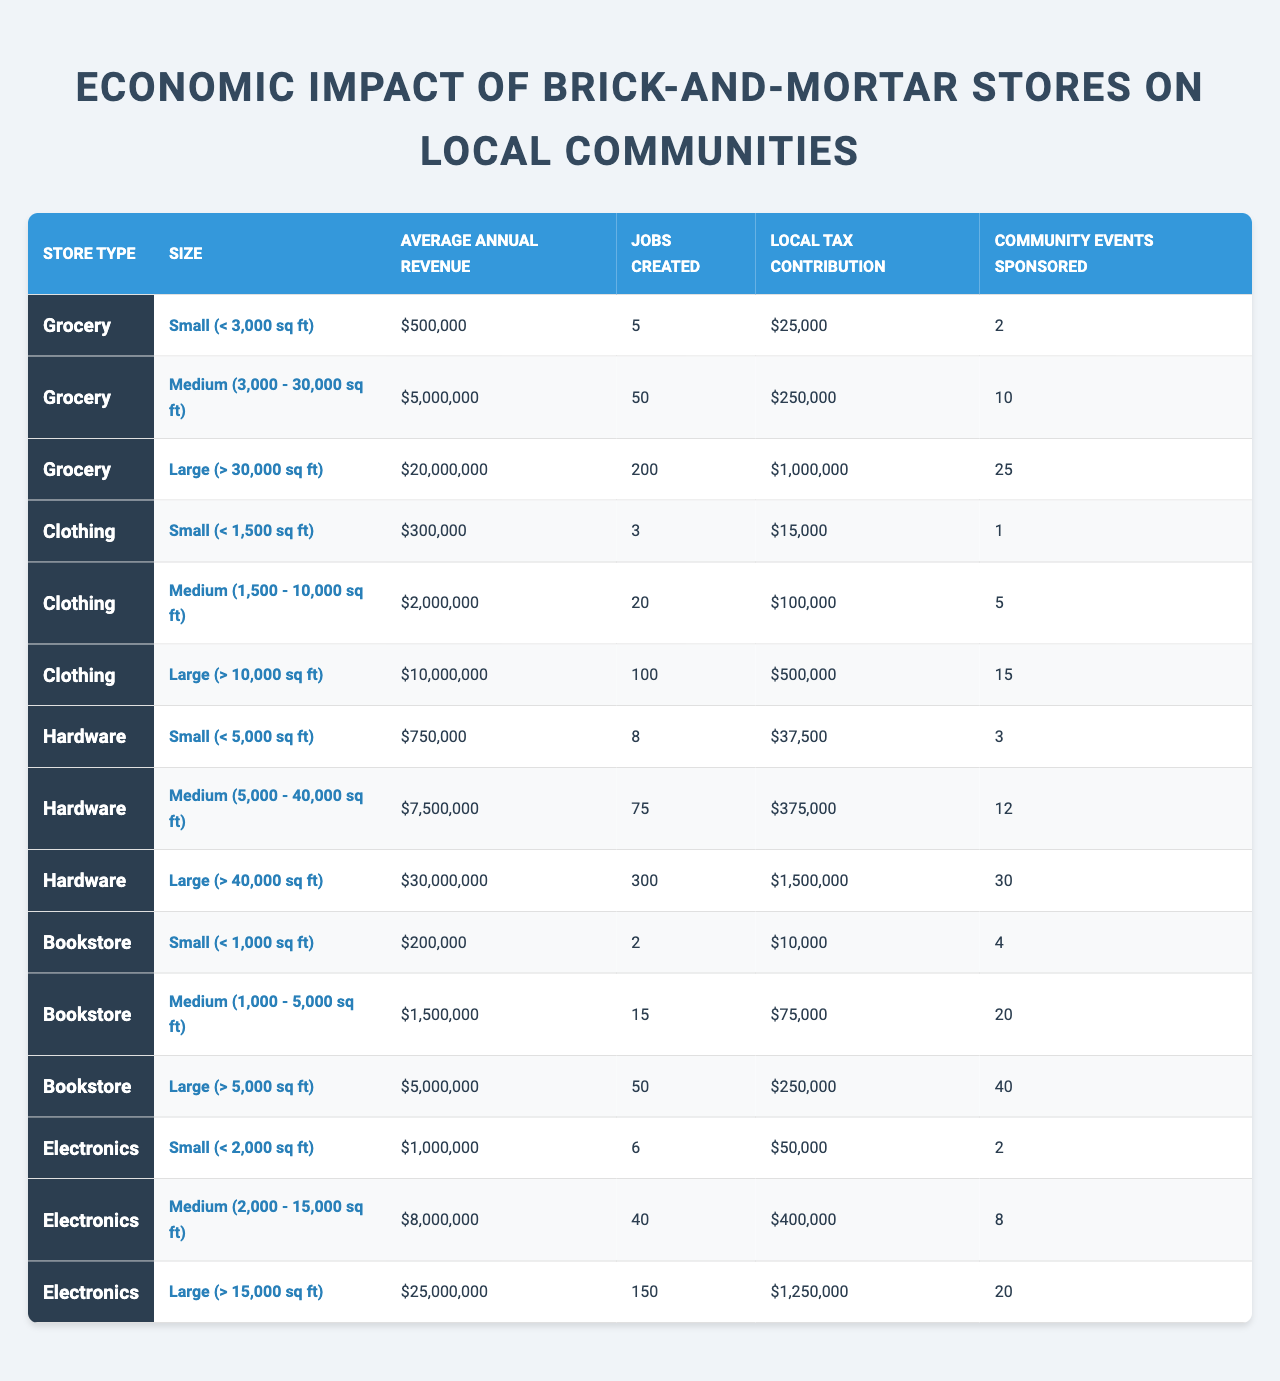What is the average annual revenue for a small grocery store? According to the table, the average annual revenue for small grocery stores (less than 3,000 sq ft) is listed as $500,000.
Answer: $500,000 How many jobs are created by medium-sized clothing stores? The table shows that medium-sized clothing stores (1,500 - 10,000 sq ft) create 20 jobs.
Answer: 20 Which store type has the highest local tax contribution for large stores? For large stores, hardware stores have the highest local tax contribution of $1,500,000 compared to other store types listed.
Answer: Hardware What is the total local tax contribution of small hardware and small clothing stores combined? For small hardware stores, the local tax contribution is $37,500, and for small clothing stores, it is $15,000. Thus, the total contribution is $37,500 + $15,000 = $52,500.
Answer: $52,500 True or False: Medium-sized grocery stores sponsor more community events than large bookstores. Medium-sized grocery stores sponsor 10 community events, while large bookstores sponsor 40 events. Therefore, the statement is false.
Answer: False What is the difference in average annual revenue between large electronics and large hardware stores? The average annual revenue for large electronics stores is $25,000,000, and for large hardware stores, it is $30,000,000. The difference is $30,000,000 - $25,000,000 = $5,000,000.
Answer: $5,000,000 How do the community events sponsored by large grocery stores compare to those sponsored by small bookstores? Large grocery stores sponsor 25 community events, while small bookstores sponsor 4 community events. Thus, large grocery stores sponsor significantly more community events.
Answer: More What is the average number of jobs created by medium-sized stores across all store types? Medium store types (grocery, clothing, hardware, bookstore, electronics) create the following jobs: 50 (grocery) + 20 (clothing) + 75 (hardware) + 15 (bookstore) + 40 (electronics) = 200 total jobs. There are 5 store types, so the average is 200/5 = 40 jobs.
Answer: 40 Which store type has the smallest local tax contribution for small store sizes? The table indicates that small clothing stores have the smallest local tax contribution of $15,000 compared to other small store types.
Answer: Clothing 